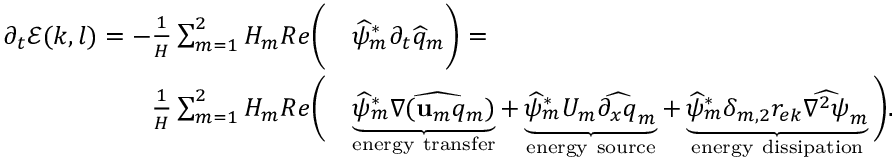<formula> <loc_0><loc_0><loc_500><loc_500>\begin{array} { r l } { \partial _ { t } \mathcal { E } ( k , l ) = - \frac { 1 } { H } \sum _ { m = 1 } ^ { 2 } H _ { m } R e \left ( } & { \widehat { \psi } _ { m } ^ { * } \partial _ { t } \widehat { q } _ { m } \right ) = } \\ { \frac { 1 } { H } \sum _ { m = 1 } ^ { 2 } H _ { m } R e \left ( } & { \underbrace { \widehat { \psi } _ { m } ^ { * } \widehat { \nabla ( u _ { m } q _ { m } } ) } _ { e n e r g y t r a n s f e r } + \underbrace { \widehat { \psi } _ { m } ^ { * } U _ { m } \widehat { \partial _ { x } q } _ { m } } _ { e n e r g y s o u r c e } + \underbrace { \widehat { \psi } _ { m } ^ { * } \delta _ { m , 2 } r _ { e k } \widehat { \nabla ^ { 2 } \psi } _ { m } } _ { e n e r g y d i s s i p a t i o n } \right ) . } \end{array}</formula> 